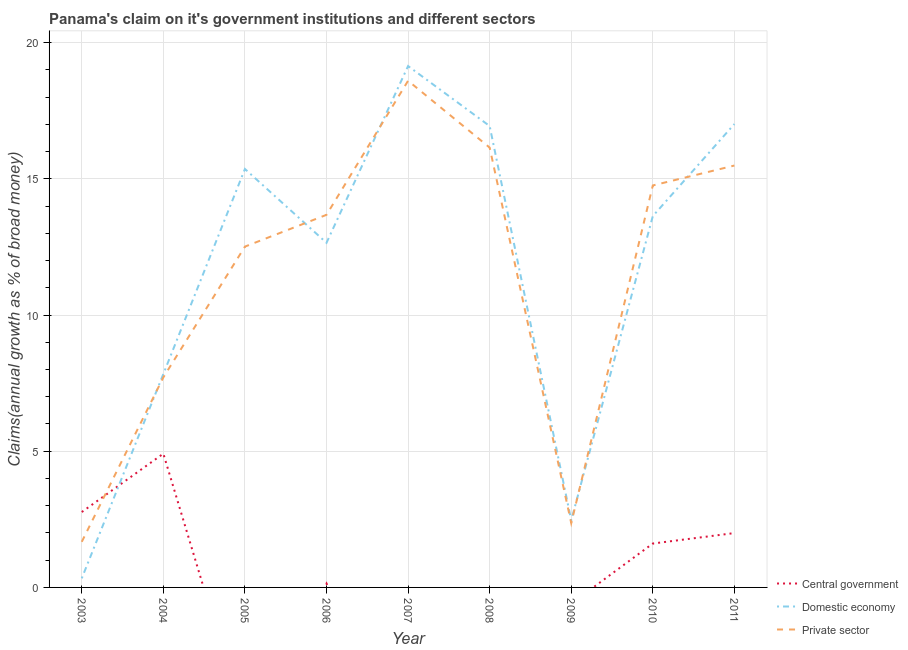Is the number of lines equal to the number of legend labels?
Offer a very short reply. No. What is the percentage of claim on the domestic economy in 2004?
Your response must be concise. 7.83. Across all years, what is the maximum percentage of claim on the domestic economy?
Your answer should be very brief. 19.14. Across all years, what is the minimum percentage of claim on the domestic economy?
Make the answer very short. 0.33. What is the total percentage of claim on the private sector in the graph?
Your answer should be compact. 102.94. What is the difference between the percentage of claim on the central government in 2006 and that in 2011?
Ensure brevity in your answer.  -1.85. What is the difference between the percentage of claim on the central government in 2004 and the percentage of claim on the domestic economy in 2005?
Make the answer very short. -10.45. What is the average percentage of claim on the central government per year?
Ensure brevity in your answer.  1.27. In the year 2009, what is the difference between the percentage of claim on the private sector and percentage of claim on the domestic economy?
Your answer should be very brief. -0.1. In how many years, is the percentage of claim on the private sector greater than 10 %?
Provide a succinct answer. 6. What is the ratio of the percentage of claim on the private sector in 2008 to that in 2010?
Provide a short and direct response. 1.09. Is the percentage of claim on the private sector in 2005 less than that in 2010?
Your response must be concise. Yes. Is the difference between the percentage of claim on the domestic economy in 2007 and 2011 greater than the difference between the percentage of claim on the private sector in 2007 and 2011?
Keep it short and to the point. No. What is the difference between the highest and the second highest percentage of claim on the central government?
Keep it short and to the point. 2.14. What is the difference between the highest and the lowest percentage of claim on the domestic economy?
Give a very brief answer. 18.81. In how many years, is the percentage of claim on the central government greater than the average percentage of claim on the central government taken over all years?
Give a very brief answer. 4. Is the sum of the percentage of claim on the domestic economy in 2005 and 2008 greater than the maximum percentage of claim on the private sector across all years?
Provide a short and direct response. Yes. Is it the case that in every year, the sum of the percentage of claim on the central government and percentage of claim on the domestic economy is greater than the percentage of claim on the private sector?
Provide a short and direct response. No. Does the percentage of claim on the private sector monotonically increase over the years?
Offer a very short reply. No. Is the percentage of claim on the private sector strictly greater than the percentage of claim on the central government over the years?
Your answer should be compact. No. How many lines are there?
Your response must be concise. 3. How many years are there in the graph?
Offer a terse response. 9. What is the difference between two consecutive major ticks on the Y-axis?
Provide a short and direct response. 5. Does the graph contain grids?
Provide a succinct answer. Yes. How many legend labels are there?
Provide a succinct answer. 3. What is the title of the graph?
Give a very brief answer. Panama's claim on it's government institutions and different sectors. What is the label or title of the Y-axis?
Provide a succinct answer. Claims(annual growth as % of broad money). What is the Claims(annual growth as % of broad money) in Central government in 2003?
Make the answer very short. 2.77. What is the Claims(annual growth as % of broad money) of Domestic economy in 2003?
Offer a terse response. 0.33. What is the Claims(annual growth as % of broad money) of Private sector in 2003?
Offer a very short reply. 1.67. What is the Claims(annual growth as % of broad money) in Central government in 2004?
Make the answer very short. 4.91. What is the Claims(annual growth as % of broad money) in Domestic economy in 2004?
Provide a short and direct response. 7.83. What is the Claims(annual growth as % of broad money) of Private sector in 2004?
Your answer should be compact. 7.71. What is the Claims(annual growth as % of broad money) of Domestic economy in 2005?
Give a very brief answer. 15.36. What is the Claims(annual growth as % of broad money) of Private sector in 2005?
Give a very brief answer. 12.51. What is the Claims(annual growth as % of broad money) in Central government in 2006?
Provide a short and direct response. 0.14. What is the Claims(annual growth as % of broad money) in Domestic economy in 2006?
Provide a short and direct response. 12.65. What is the Claims(annual growth as % of broad money) of Private sector in 2006?
Ensure brevity in your answer.  13.68. What is the Claims(annual growth as % of broad money) in Domestic economy in 2007?
Ensure brevity in your answer.  19.14. What is the Claims(annual growth as % of broad money) of Private sector in 2007?
Give a very brief answer. 18.6. What is the Claims(annual growth as % of broad money) of Central government in 2008?
Your answer should be very brief. 0. What is the Claims(annual growth as % of broad money) of Domestic economy in 2008?
Give a very brief answer. 16.94. What is the Claims(annual growth as % of broad money) of Private sector in 2008?
Your answer should be compact. 16.15. What is the Claims(annual growth as % of broad money) in Central government in 2009?
Ensure brevity in your answer.  0. What is the Claims(annual growth as % of broad money) of Domestic economy in 2009?
Provide a short and direct response. 2.46. What is the Claims(annual growth as % of broad money) of Private sector in 2009?
Your response must be concise. 2.36. What is the Claims(annual growth as % of broad money) in Central government in 2010?
Provide a short and direct response. 1.61. What is the Claims(annual growth as % of broad money) of Domestic economy in 2010?
Ensure brevity in your answer.  13.63. What is the Claims(annual growth as % of broad money) in Private sector in 2010?
Provide a succinct answer. 14.76. What is the Claims(annual growth as % of broad money) of Central government in 2011?
Provide a short and direct response. 2. What is the Claims(annual growth as % of broad money) in Domestic economy in 2011?
Make the answer very short. 17.01. What is the Claims(annual growth as % of broad money) in Private sector in 2011?
Your answer should be very brief. 15.49. Across all years, what is the maximum Claims(annual growth as % of broad money) of Central government?
Offer a terse response. 4.91. Across all years, what is the maximum Claims(annual growth as % of broad money) in Domestic economy?
Your response must be concise. 19.14. Across all years, what is the maximum Claims(annual growth as % of broad money) of Private sector?
Your answer should be compact. 18.6. Across all years, what is the minimum Claims(annual growth as % of broad money) in Central government?
Ensure brevity in your answer.  0. Across all years, what is the minimum Claims(annual growth as % of broad money) of Domestic economy?
Offer a terse response. 0.33. Across all years, what is the minimum Claims(annual growth as % of broad money) in Private sector?
Your answer should be compact. 1.67. What is the total Claims(annual growth as % of broad money) in Central government in the graph?
Give a very brief answer. 11.43. What is the total Claims(annual growth as % of broad money) in Domestic economy in the graph?
Ensure brevity in your answer.  105.37. What is the total Claims(annual growth as % of broad money) in Private sector in the graph?
Your answer should be very brief. 102.94. What is the difference between the Claims(annual growth as % of broad money) in Central government in 2003 and that in 2004?
Your answer should be compact. -2.14. What is the difference between the Claims(annual growth as % of broad money) of Domestic economy in 2003 and that in 2004?
Provide a short and direct response. -7.5. What is the difference between the Claims(annual growth as % of broad money) in Private sector in 2003 and that in 2004?
Provide a short and direct response. -6.04. What is the difference between the Claims(annual growth as % of broad money) in Domestic economy in 2003 and that in 2005?
Your answer should be compact. -15.03. What is the difference between the Claims(annual growth as % of broad money) in Private sector in 2003 and that in 2005?
Your response must be concise. -10.84. What is the difference between the Claims(annual growth as % of broad money) of Central government in 2003 and that in 2006?
Your answer should be compact. 2.62. What is the difference between the Claims(annual growth as % of broad money) in Domestic economy in 2003 and that in 2006?
Your answer should be very brief. -12.32. What is the difference between the Claims(annual growth as % of broad money) in Private sector in 2003 and that in 2006?
Keep it short and to the point. -12. What is the difference between the Claims(annual growth as % of broad money) of Domestic economy in 2003 and that in 2007?
Offer a very short reply. -18.81. What is the difference between the Claims(annual growth as % of broad money) in Private sector in 2003 and that in 2007?
Offer a very short reply. -16.93. What is the difference between the Claims(annual growth as % of broad money) of Domestic economy in 2003 and that in 2008?
Make the answer very short. -16.61. What is the difference between the Claims(annual growth as % of broad money) of Private sector in 2003 and that in 2008?
Provide a short and direct response. -14.47. What is the difference between the Claims(annual growth as % of broad money) of Domestic economy in 2003 and that in 2009?
Ensure brevity in your answer.  -2.13. What is the difference between the Claims(annual growth as % of broad money) of Private sector in 2003 and that in 2009?
Offer a terse response. -0.69. What is the difference between the Claims(annual growth as % of broad money) of Central government in 2003 and that in 2010?
Offer a terse response. 1.16. What is the difference between the Claims(annual growth as % of broad money) in Domestic economy in 2003 and that in 2010?
Give a very brief answer. -13.3. What is the difference between the Claims(annual growth as % of broad money) of Private sector in 2003 and that in 2010?
Provide a succinct answer. -13.08. What is the difference between the Claims(annual growth as % of broad money) of Central government in 2003 and that in 2011?
Make the answer very short. 0.77. What is the difference between the Claims(annual growth as % of broad money) of Domestic economy in 2003 and that in 2011?
Provide a short and direct response. -16.68. What is the difference between the Claims(annual growth as % of broad money) of Private sector in 2003 and that in 2011?
Your answer should be compact. -13.81. What is the difference between the Claims(annual growth as % of broad money) of Domestic economy in 2004 and that in 2005?
Your answer should be compact. -7.53. What is the difference between the Claims(annual growth as % of broad money) of Private sector in 2004 and that in 2005?
Provide a succinct answer. -4.8. What is the difference between the Claims(annual growth as % of broad money) in Central government in 2004 and that in 2006?
Your answer should be compact. 4.77. What is the difference between the Claims(annual growth as % of broad money) of Domestic economy in 2004 and that in 2006?
Make the answer very short. -4.82. What is the difference between the Claims(annual growth as % of broad money) in Private sector in 2004 and that in 2006?
Offer a very short reply. -5.97. What is the difference between the Claims(annual growth as % of broad money) of Domestic economy in 2004 and that in 2007?
Give a very brief answer. -11.31. What is the difference between the Claims(annual growth as % of broad money) of Private sector in 2004 and that in 2007?
Provide a succinct answer. -10.89. What is the difference between the Claims(annual growth as % of broad money) of Domestic economy in 2004 and that in 2008?
Keep it short and to the point. -9.1. What is the difference between the Claims(annual growth as % of broad money) of Private sector in 2004 and that in 2008?
Keep it short and to the point. -8.44. What is the difference between the Claims(annual growth as % of broad money) in Domestic economy in 2004 and that in 2009?
Give a very brief answer. 5.37. What is the difference between the Claims(annual growth as % of broad money) in Private sector in 2004 and that in 2009?
Provide a succinct answer. 5.35. What is the difference between the Claims(annual growth as % of broad money) of Central government in 2004 and that in 2010?
Your answer should be compact. 3.3. What is the difference between the Claims(annual growth as % of broad money) in Domestic economy in 2004 and that in 2010?
Provide a succinct answer. -5.8. What is the difference between the Claims(annual growth as % of broad money) in Private sector in 2004 and that in 2010?
Keep it short and to the point. -7.05. What is the difference between the Claims(annual growth as % of broad money) in Central government in 2004 and that in 2011?
Your answer should be compact. 2.92. What is the difference between the Claims(annual growth as % of broad money) in Domestic economy in 2004 and that in 2011?
Provide a short and direct response. -9.18. What is the difference between the Claims(annual growth as % of broad money) of Private sector in 2004 and that in 2011?
Offer a terse response. -7.78. What is the difference between the Claims(annual growth as % of broad money) of Domestic economy in 2005 and that in 2006?
Offer a very short reply. 2.71. What is the difference between the Claims(annual growth as % of broad money) in Private sector in 2005 and that in 2006?
Ensure brevity in your answer.  -1.17. What is the difference between the Claims(annual growth as % of broad money) in Domestic economy in 2005 and that in 2007?
Your answer should be compact. -3.78. What is the difference between the Claims(annual growth as % of broad money) of Private sector in 2005 and that in 2007?
Make the answer very short. -6.09. What is the difference between the Claims(annual growth as % of broad money) in Domestic economy in 2005 and that in 2008?
Your response must be concise. -1.58. What is the difference between the Claims(annual growth as % of broad money) of Private sector in 2005 and that in 2008?
Ensure brevity in your answer.  -3.64. What is the difference between the Claims(annual growth as % of broad money) of Domestic economy in 2005 and that in 2009?
Your answer should be compact. 12.9. What is the difference between the Claims(annual growth as % of broad money) of Private sector in 2005 and that in 2009?
Your answer should be very brief. 10.15. What is the difference between the Claims(annual growth as % of broad money) of Domestic economy in 2005 and that in 2010?
Ensure brevity in your answer.  1.73. What is the difference between the Claims(annual growth as % of broad money) of Private sector in 2005 and that in 2010?
Offer a terse response. -2.25. What is the difference between the Claims(annual growth as % of broad money) of Domestic economy in 2005 and that in 2011?
Provide a succinct answer. -1.65. What is the difference between the Claims(annual growth as % of broad money) of Private sector in 2005 and that in 2011?
Keep it short and to the point. -2.98. What is the difference between the Claims(annual growth as % of broad money) in Domestic economy in 2006 and that in 2007?
Ensure brevity in your answer.  -6.49. What is the difference between the Claims(annual growth as % of broad money) in Private sector in 2006 and that in 2007?
Keep it short and to the point. -4.92. What is the difference between the Claims(annual growth as % of broad money) of Domestic economy in 2006 and that in 2008?
Your answer should be very brief. -4.29. What is the difference between the Claims(annual growth as % of broad money) of Private sector in 2006 and that in 2008?
Ensure brevity in your answer.  -2.47. What is the difference between the Claims(annual growth as % of broad money) in Domestic economy in 2006 and that in 2009?
Keep it short and to the point. 10.19. What is the difference between the Claims(annual growth as % of broad money) of Private sector in 2006 and that in 2009?
Offer a very short reply. 11.32. What is the difference between the Claims(annual growth as % of broad money) of Central government in 2006 and that in 2010?
Keep it short and to the point. -1.47. What is the difference between the Claims(annual growth as % of broad money) in Domestic economy in 2006 and that in 2010?
Provide a short and direct response. -0.98. What is the difference between the Claims(annual growth as % of broad money) of Private sector in 2006 and that in 2010?
Provide a short and direct response. -1.08. What is the difference between the Claims(annual growth as % of broad money) in Central government in 2006 and that in 2011?
Provide a succinct answer. -1.85. What is the difference between the Claims(annual growth as % of broad money) of Domestic economy in 2006 and that in 2011?
Offer a terse response. -4.36. What is the difference between the Claims(annual growth as % of broad money) in Private sector in 2006 and that in 2011?
Your response must be concise. -1.81. What is the difference between the Claims(annual growth as % of broad money) of Domestic economy in 2007 and that in 2008?
Your answer should be compact. 2.2. What is the difference between the Claims(annual growth as % of broad money) of Private sector in 2007 and that in 2008?
Keep it short and to the point. 2.45. What is the difference between the Claims(annual growth as % of broad money) of Domestic economy in 2007 and that in 2009?
Offer a very short reply. 16.68. What is the difference between the Claims(annual growth as % of broad money) in Private sector in 2007 and that in 2009?
Give a very brief answer. 16.24. What is the difference between the Claims(annual growth as % of broad money) in Domestic economy in 2007 and that in 2010?
Offer a terse response. 5.51. What is the difference between the Claims(annual growth as % of broad money) of Private sector in 2007 and that in 2010?
Your answer should be very brief. 3.84. What is the difference between the Claims(annual growth as % of broad money) in Domestic economy in 2007 and that in 2011?
Your response must be concise. 2.13. What is the difference between the Claims(annual growth as % of broad money) of Private sector in 2007 and that in 2011?
Your answer should be compact. 3.11. What is the difference between the Claims(annual growth as % of broad money) in Domestic economy in 2008 and that in 2009?
Provide a short and direct response. 14.48. What is the difference between the Claims(annual growth as % of broad money) in Private sector in 2008 and that in 2009?
Your response must be concise. 13.78. What is the difference between the Claims(annual growth as % of broad money) in Domestic economy in 2008 and that in 2010?
Give a very brief answer. 3.31. What is the difference between the Claims(annual growth as % of broad money) in Private sector in 2008 and that in 2010?
Your response must be concise. 1.39. What is the difference between the Claims(annual growth as % of broad money) of Domestic economy in 2008 and that in 2011?
Provide a succinct answer. -0.07. What is the difference between the Claims(annual growth as % of broad money) in Private sector in 2008 and that in 2011?
Offer a terse response. 0.66. What is the difference between the Claims(annual growth as % of broad money) of Domestic economy in 2009 and that in 2010?
Provide a succinct answer. -11.17. What is the difference between the Claims(annual growth as % of broad money) in Private sector in 2009 and that in 2010?
Ensure brevity in your answer.  -12.39. What is the difference between the Claims(annual growth as % of broad money) of Domestic economy in 2009 and that in 2011?
Your answer should be compact. -14.55. What is the difference between the Claims(annual growth as % of broad money) in Private sector in 2009 and that in 2011?
Offer a terse response. -13.13. What is the difference between the Claims(annual growth as % of broad money) in Central government in 2010 and that in 2011?
Give a very brief answer. -0.38. What is the difference between the Claims(annual growth as % of broad money) in Domestic economy in 2010 and that in 2011?
Give a very brief answer. -3.38. What is the difference between the Claims(annual growth as % of broad money) of Private sector in 2010 and that in 2011?
Your response must be concise. -0.73. What is the difference between the Claims(annual growth as % of broad money) of Central government in 2003 and the Claims(annual growth as % of broad money) of Domestic economy in 2004?
Your response must be concise. -5.07. What is the difference between the Claims(annual growth as % of broad money) in Central government in 2003 and the Claims(annual growth as % of broad money) in Private sector in 2004?
Your answer should be compact. -4.94. What is the difference between the Claims(annual growth as % of broad money) in Domestic economy in 2003 and the Claims(annual growth as % of broad money) in Private sector in 2004?
Provide a short and direct response. -7.38. What is the difference between the Claims(annual growth as % of broad money) of Central government in 2003 and the Claims(annual growth as % of broad money) of Domestic economy in 2005?
Offer a very short reply. -12.59. What is the difference between the Claims(annual growth as % of broad money) in Central government in 2003 and the Claims(annual growth as % of broad money) in Private sector in 2005?
Your answer should be very brief. -9.74. What is the difference between the Claims(annual growth as % of broad money) of Domestic economy in 2003 and the Claims(annual growth as % of broad money) of Private sector in 2005?
Your answer should be very brief. -12.18. What is the difference between the Claims(annual growth as % of broad money) in Central government in 2003 and the Claims(annual growth as % of broad money) in Domestic economy in 2006?
Make the answer very short. -9.88. What is the difference between the Claims(annual growth as % of broad money) of Central government in 2003 and the Claims(annual growth as % of broad money) of Private sector in 2006?
Ensure brevity in your answer.  -10.91. What is the difference between the Claims(annual growth as % of broad money) in Domestic economy in 2003 and the Claims(annual growth as % of broad money) in Private sector in 2006?
Offer a very short reply. -13.35. What is the difference between the Claims(annual growth as % of broad money) in Central government in 2003 and the Claims(annual growth as % of broad money) in Domestic economy in 2007?
Your answer should be very brief. -16.37. What is the difference between the Claims(annual growth as % of broad money) in Central government in 2003 and the Claims(annual growth as % of broad money) in Private sector in 2007?
Your answer should be very brief. -15.83. What is the difference between the Claims(annual growth as % of broad money) in Domestic economy in 2003 and the Claims(annual growth as % of broad money) in Private sector in 2007?
Make the answer very short. -18.27. What is the difference between the Claims(annual growth as % of broad money) in Central government in 2003 and the Claims(annual growth as % of broad money) in Domestic economy in 2008?
Keep it short and to the point. -14.17. What is the difference between the Claims(annual growth as % of broad money) in Central government in 2003 and the Claims(annual growth as % of broad money) in Private sector in 2008?
Provide a succinct answer. -13.38. What is the difference between the Claims(annual growth as % of broad money) in Domestic economy in 2003 and the Claims(annual growth as % of broad money) in Private sector in 2008?
Give a very brief answer. -15.81. What is the difference between the Claims(annual growth as % of broad money) in Central government in 2003 and the Claims(annual growth as % of broad money) in Domestic economy in 2009?
Give a very brief answer. 0.31. What is the difference between the Claims(annual growth as % of broad money) in Central government in 2003 and the Claims(annual growth as % of broad money) in Private sector in 2009?
Offer a very short reply. 0.4. What is the difference between the Claims(annual growth as % of broad money) of Domestic economy in 2003 and the Claims(annual growth as % of broad money) of Private sector in 2009?
Provide a succinct answer. -2.03. What is the difference between the Claims(annual growth as % of broad money) of Central government in 2003 and the Claims(annual growth as % of broad money) of Domestic economy in 2010?
Provide a short and direct response. -10.86. What is the difference between the Claims(annual growth as % of broad money) of Central government in 2003 and the Claims(annual growth as % of broad money) of Private sector in 2010?
Ensure brevity in your answer.  -11.99. What is the difference between the Claims(annual growth as % of broad money) in Domestic economy in 2003 and the Claims(annual growth as % of broad money) in Private sector in 2010?
Your answer should be very brief. -14.42. What is the difference between the Claims(annual growth as % of broad money) of Central government in 2003 and the Claims(annual growth as % of broad money) of Domestic economy in 2011?
Provide a short and direct response. -14.24. What is the difference between the Claims(annual growth as % of broad money) of Central government in 2003 and the Claims(annual growth as % of broad money) of Private sector in 2011?
Give a very brief answer. -12.72. What is the difference between the Claims(annual growth as % of broad money) in Domestic economy in 2003 and the Claims(annual growth as % of broad money) in Private sector in 2011?
Your answer should be very brief. -15.15. What is the difference between the Claims(annual growth as % of broad money) of Central government in 2004 and the Claims(annual growth as % of broad money) of Domestic economy in 2005?
Give a very brief answer. -10.45. What is the difference between the Claims(annual growth as % of broad money) of Central government in 2004 and the Claims(annual growth as % of broad money) of Private sector in 2005?
Your answer should be compact. -7.6. What is the difference between the Claims(annual growth as % of broad money) in Domestic economy in 2004 and the Claims(annual growth as % of broad money) in Private sector in 2005?
Offer a very short reply. -4.68. What is the difference between the Claims(annual growth as % of broad money) of Central government in 2004 and the Claims(annual growth as % of broad money) of Domestic economy in 2006?
Provide a succinct answer. -7.74. What is the difference between the Claims(annual growth as % of broad money) in Central government in 2004 and the Claims(annual growth as % of broad money) in Private sector in 2006?
Offer a terse response. -8.77. What is the difference between the Claims(annual growth as % of broad money) of Domestic economy in 2004 and the Claims(annual growth as % of broad money) of Private sector in 2006?
Provide a short and direct response. -5.84. What is the difference between the Claims(annual growth as % of broad money) in Central government in 2004 and the Claims(annual growth as % of broad money) in Domestic economy in 2007?
Offer a terse response. -14.23. What is the difference between the Claims(annual growth as % of broad money) of Central government in 2004 and the Claims(annual growth as % of broad money) of Private sector in 2007?
Your response must be concise. -13.69. What is the difference between the Claims(annual growth as % of broad money) in Domestic economy in 2004 and the Claims(annual growth as % of broad money) in Private sector in 2007?
Make the answer very short. -10.77. What is the difference between the Claims(annual growth as % of broad money) of Central government in 2004 and the Claims(annual growth as % of broad money) of Domestic economy in 2008?
Ensure brevity in your answer.  -12.03. What is the difference between the Claims(annual growth as % of broad money) of Central government in 2004 and the Claims(annual growth as % of broad money) of Private sector in 2008?
Offer a terse response. -11.24. What is the difference between the Claims(annual growth as % of broad money) in Domestic economy in 2004 and the Claims(annual growth as % of broad money) in Private sector in 2008?
Ensure brevity in your answer.  -8.31. What is the difference between the Claims(annual growth as % of broad money) in Central government in 2004 and the Claims(annual growth as % of broad money) in Domestic economy in 2009?
Your response must be concise. 2.45. What is the difference between the Claims(annual growth as % of broad money) in Central government in 2004 and the Claims(annual growth as % of broad money) in Private sector in 2009?
Offer a terse response. 2.55. What is the difference between the Claims(annual growth as % of broad money) of Domestic economy in 2004 and the Claims(annual growth as % of broad money) of Private sector in 2009?
Offer a very short reply. 5.47. What is the difference between the Claims(annual growth as % of broad money) of Central government in 2004 and the Claims(annual growth as % of broad money) of Domestic economy in 2010?
Your answer should be very brief. -8.72. What is the difference between the Claims(annual growth as % of broad money) in Central government in 2004 and the Claims(annual growth as % of broad money) in Private sector in 2010?
Your answer should be compact. -9.85. What is the difference between the Claims(annual growth as % of broad money) in Domestic economy in 2004 and the Claims(annual growth as % of broad money) in Private sector in 2010?
Offer a terse response. -6.92. What is the difference between the Claims(annual growth as % of broad money) in Central government in 2004 and the Claims(annual growth as % of broad money) in Domestic economy in 2011?
Offer a terse response. -12.1. What is the difference between the Claims(annual growth as % of broad money) in Central government in 2004 and the Claims(annual growth as % of broad money) in Private sector in 2011?
Your answer should be compact. -10.58. What is the difference between the Claims(annual growth as % of broad money) of Domestic economy in 2004 and the Claims(annual growth as % of broad money) of Private sector in 2011?
Give a very brief answer. -7.65. What is the difference between the Claims(annual growth as % of broad money) of Domestic economy in 2005 and the Claims(annual growth as % of broad money) of Private sector in 2006?
Give a very brief answer. 1.68. What is the difference between the Claims(annual growth as % of broad money) in Domestic economy in 2005 and the Claims(annual growth as % of broad money) in Private sector in 2007?
Your answer should be very brief. -3.24. What is the difference between the Claims(annual growth as % of broad money) of Domestic economy in 2005 and the Claims(annual growth as % of broad money) of Private sector in 2008?
Provide a succinct answer. -0.78. What is the difference between the Claims(annual growth as % of broad money) of Domestic economy in 2005 and the Claims(annual growth as % of broad money) of Private sector in 2009?
Give a very brief answer. 13. What is the difference between the Claims(annual growth as % of broad money) of Domestic economy in 2005 and the Claims(annual growth as % of broad money) of Private sector in 2010?
Your response must be concise. 0.6. What is the difference between the Claims(annual growth as % of broad money) in Domestic economy in 2005 and the Claims(annual growth as % of broad money) in Private sector in 2011?
Make the answer very short. -0.13. What is the difference between the Claims(annual growth as % of broad money) in Central government in 2006 and the Claims(annual growth as % of broad money) in Domestic economy in 2007?
Offer a terse response. -19. What is the difference between the Claims(annual growth as % of broad money) of Central government in 2006 and the Claims(annual growth as % of broad money) of Private sector in 2007?
Ensure brevity in your answer.  -18.46. What is the difference between the Claims(annual growth as % of broad money) of Domestic economy in 2006 and the Claims(annual growth as % of broad money) of Private sector in 2007?
Provide a short and direct response. -5.95. What is the difference between the Claims(annual growth as % of broad money) of Central government in 2006 and the Claims(annual growth as % of broad money) of Domestic economy in 2008?
Your answer should be very brief. -16.79. What is the difference between the Claims(annual growth as % of broad money) in Central government in 2006 and the Claims(annual growth as % of broad money) in Private sector in 2008?
Your answer should be very brief. -16. What is the difference between the Claims(annual growth as % of broad money) in Domestic economy in 2006 and the Claims(annual growth as % of broad money) in Private sector in 2008?
Make the answer very short. -3.5. What is the difference between the Claims(annual growth as % of broad money) of Central government in 2006 and the Claims(annual growth as % of broad money) of Domestic economy in 2009?
Offer a very short reply. -2.32. What is the difference between the Claims(annual growth as % of broad money) of Central government in 2006 and the Claims(annual growth as % of broad money) of Private sector in 2009?
Ensure brevity in your answer.  -2.22. What is the difference between the Claims(annual growth as % of broad money) in Domestic economy in 2006 and the Claims(annual growth as % of broad money) in Private sector in 2009?
Your answer should be compact. 10.29. What is the difference between the Claims(annual growth as % of broad money) of Central government in 2006 and the Claims(annual growth as % of broad money) of Domestic economy in 2010?
Give a very brief answer. -13.49. What is the difference between the Claims(annual growth as % of broad money) of Central government in 2006 and the Claims(annual growth as % of broad money) of Private sector in 2010?
Make the answer very short. -14.61. What is the difference between the Claims(annual growth as % of broad money) of Domestic economy in 2006 and the Claims(annual growth as % of broad money) of Private sector in 2010?
Provide a short and direct response. -2.11. What is the difference between the Claims(annual growth as % of broad money) of Central government in 2006 and the Claims(annual growth as % of broad money) of Domestic economy in 2011?
Ensure brevity in your answer.  -16.87. What is the difference between the Claims(annual growth as % of broad money) in Central government in 2006 and the Claims(annual growth as % of broad money) in Private sector in 2011?
Your answer should be very brief. -15.34. What is the difference between the Claims(annual growth as % of broad money) in Domestic economy in 2006 and the Claims(annual growth as % of broad money) in Private sector in 2011?
Ensure brevity in your answer.  -2.84. What is the difference between the Claims(annual growth as % of broad money) of Domestic economy in 2007 and the Claims(annual growth as % of broad money) of Private sector in 2008?
Keep it short and to the point. 2.99. What is the difference between the Claims(annual growth as % of broad money) in Domestic economy in 2007 and the Claims(annual growth as % of broad money) in Private sector in 2009?
Keep it short and to the point. 16.78. What is the difference between the Claims(annual growth as % of broad money) in Domestic economy in 2007 and the Claims(annual growth as % of broad money) in Private sector in 2010?
Your answer should be very brief. 4.38. What is the difference between the Claims(annual growth as % of broad money) in Domestic economy in 2007 and the Claims(annual growth as % of broad money) in Private sector in 2011?
Offer a terse response. 3.65. What is the difference between the Claims(annual growth as % of broad money) of Domestic economy in 2008 and the Claims(annual growth as % of broad money) of Private sector in 2009?
Your response must be concise. 14.58. What is the difference between the Claims(annual growth as % of broad money) in Domestic economy in 2008 and the Claims(annual growth as % of broad money) in Private sector in 2010?
Your answer should be very brief. 2.18. What is the difference between the Claims(annual growth as % of broad money) in Domestic economy in 2008 and the Claims(annual growth as % of broad money) in Private sector in 2011?
Provide a short and direct response. 1.45. What is the difference between the Claims(annual growth as % of broad money) in Domestic economy in 2009 and the Claims(annual growth as % of broad money) in Private sector in 2010?
Offer a terse response. -12.3. What is the difference between the Claims(annual growth as % of broad money) of Domestic economy in 2009 and the Claims(annual growth as % of broad money) of Private sector in 2011?
Make the answer very short. -13.03. What is the difference between the Claims(annual growth as % of broad money) of Central government in 2010 and the Claims(annual growth as % of broad money) of Domestic economy in 2011?
Your answer should be very brief. -15.4. What is the difference between the Claims(annual growth as % of broad money) of Central government in 2010 and the Claims(annual growth as % of broad money) of Private sector in 2011?
Ensure brevity in your answer.  -13.88. What is the difference between the Claims(annual growth as % of broad money) of Domestic economy in 2010 and the Claims(annual growth as % of broad money) of Private sector in 2011?
Offer a very short reply. -1.86. What is the average Claims(annual growth as % of broad money) of Central government per year?
Offer a terse response. 1.27. What is the average Claims(annual growth as % of broad money) of Domestic economy per year?
Your answer should be very brief. 11.71. What is the average Claims(annual growth as % of broad money) of Private sector per year?
Ensure brevity in your answer.  11.44. In the year 2003, what is the difference between the Claims(annual growth as % of broad money) of Central government and Claims(annual growth as % of broad money) of Domestic economy?
Your response must be concise. 2.43. In the year 2003, what is the difference between the Claims(annual growth as % of broad money) of Central government and Claims(annual growth as % of broad money) of Private sector?
Provide a short and direct response. 1.09. In the year 2003, what is the difference between the Claims(annual growth as % of broad money) of Domestic economy and Claims(annual growth as % of broad money) of Private sector?
Your response must be concise. -1.34. In the year 2004, what is the difference between the Claims(annual growth as % of broad money) of Central government and Claims(annual growth as % of broad money) of Domestic economy?
Your answer should be compact. -2.92. In the year 2004, what is the difference between the Claims(annual growth as % of broad money) in Central government and Claims(annual growth as % of broad money) in Private sector?
Make the answer very short. -2.8. In the year 2004, what is the difference between the Claims(annual growth as % of broad money) of Domestic economy and Claims(annual growth as % of broad money) of Private sector?
Your answer should be compact. 0.12. In the year 2005, what is the difference between the Claims(annual growth as % of broad money) of Domestic economy and Claims(annual growth as % of broad money) of Private sector?
Your response must be concise. 2.85. In the year 2006, what is the difference between the Claims(annual growth as % of broad money) of Central government and Claims(annual growth as % of broad money) of Domestic economy?
Your response must be concise. -12.51. In the year 2006, what is the difference between the Claims(annual growth as % of broad money) in Central government and Claims(annual growth as % of broad money) in Private sector?
Keep it short and to the point. -13.53. In the year 2006, what is the difference between the Claims(annual growth as % of broad money) in Domestic economy and Claims(annual growth as % of broad money) in Private sector?
Ensure brevity in your answer.  -1.03. In the year 2007, what is the difference between the Claims(annual growth as % of broad money) in Domestic economy and Claims(annual growth as % of broad money) in Private sector?
Make the answer very short. 0.54. In the year 2008, what is the difference between the Claims(annual growth as % of broad money) of Domestic economy and Claims(annual growth as % of broad money) of Private sector?
Your answer should be compact. 0.79. In the year 2009, what is the difference between the Claims(annual growth as % of broad money) in Domestic economy and Claims(annual growth as % of broad money) in Private sector?
Offer a very short reply. 0.1. In the year 2010, what is the difference between the Claims(annual growth as % of broad money) in Central government and Claims(annual growth as % of broad money) in Domestic economy?
Ensure brevity in your answer.  -12.02. In the year 2010, what is the difference between the Claims(annual growth as % of broad money) of Central government and Claims(annual growth as % of broad money) of Private sector?
Provide a short and direct response. -13.15. In the year 2010, what is the difference between the Claims(annual growth as % of broad money) of Domestic economy and Claims(annual growth as % of broad money) of Private sector?
Your response must be concise. -1.13. In the year 2011, what is the difference between the Claims(annual growth as % of broad money) in Central government and Claims(annual growth as % of broad money) in Domestic economy?
Give a very brief answer. -15.02. In the year 2011, what is the difference between the Claims(annual growth as % of broad money) of Central government and Claims(annual growth as % of broad money) of Private sector?
Provide a succinct answer. -13.49. In the year 2011, what is the difference between the Claims(annual growth as % of broad money) in Domestic economy and Claims(annual growth as % of broad money) in Private sector?
Provide a short and direct response. 1.52. What is the ratio of the Claims(annual growth as % of broad money) of Central government in 2003 to that in 2004?
Offer a very short reply. 0.56. What is the ratio of the Claims(annual growth as % of broad money) of Domestic economy in 2003 to that in 2004?
Ensure brevity in your answer.  0.04. What is the ratio of the Claims(annual growth as % of broad money) of Private sector in 2003 to that in 2004?
Provide a short and direct response. 0.22. What is the ratio of the Claims(annual growth as % of broad money) in Domestic economy in 2003 to that in 2005?
Your answer should be very brief. 0.02. What is the ratio of the Claims(annual growth as % of broad money) in Private sector in 2003 to that in 2005?
Ensure brevity in your answer.  0.13. What is the ratio of the Claims(annual growth as % of broad money) of Central government in 2003 to that in 2006?
Your answer should be very brief. 19.18. What is the ratio of the Claims(annual growth as % of broad money) in Domestic economy in 2003 to that in 2006?
Your answer should be very brief. 0.03. What is the ratio of the Claims(annual growth as % of broad money) in Private sector in 2003 to that in 2006?
Provide a short and direct response. 0.12. What is the ratio of the Claims(annual growth as % of broad money) of Domestic economy in 2003 to that in 2007?
Give a very brief answer. 0.02. What is the ratio of the Claims(annual growth as % of broad money) of Private sector in 2003 to that in 2007?
Your response must be concise. 0.09. What is the ratio of the Claims(annual growth as % of broad money) of Domestic economy in 2003 to that in 2008?
Your answer should be compact. 0.02. What is the ratio of the Claims(annual growth as % of broad money) in Private sector in 2003 to that in 2008?
Ensure brevity in your answer.  0.1. What is the ratio of the Claims(annual growth as % of broad money) in Domestic economy in 2003 to that in 2009?
Ensure brevity in your answer.  0.14. What is the ratio of the Claims(annual growth as % of broad money) in Private sector in 2003 to that in 2009?
Keep it short and to the point. 0.71. What is the ratio of the Claims(annual growth as % of broad money) in Central government in 2003 to that in 2010?
Offer a very short reply. 1.72. What is the ratio of the Claims(annual growth as % of broad money) in Domestic economy in 2003 to that in 2010?
Offer a terse response. 0.02. What is the ratio of the Claims(annual growth as % of broad money) in Private sector in 2003 to that in 2010?
Ensure brevity in your answer.  0.11. What is the ratio of the Claims(annual growth as % of broad money) in Central government in 2003 to that in 2011?
Your response must be concise. 1.39. What is the ratio of the Claims(annual growth as % of broad money) in Domestic economy in 2003 to that in 2011?
Provide a succinct answer. 0.02. What is the ratio of the Claims(annual growth as % of broad money) of Private sector in 2003 to that in 2011?
Give a very brief answer. 0.11. What is the ratio of the Claims(annual growth as % of broad money) of Domestic economy in 2004 to that in 2005?
Your answer should be very brief. 0.51. What is the ratio of the Claims(annual growth as % of broad money) in Private sector in 2004 to that in 2005?
Keep it short and to the point. 0.62. What is the ratio of the Claims(annual growth as % of broad money) of Central government in 2004 to that in 2006?
Offer a terse response. 34.04. What is the ratio of the Claims(annual growth as % of broad money) in Domestic economy in 2004 to that in 2006?
Offer a terse response. 0.62. What is the ratio of the Claims(annual growth as % of broad money) of Private sector in 2004 to that in 2006?
Provide a short and direct response. 0.56. What is the ratio of the Claims(annual growth as % of broad money) in Domestic economy in 2004 to that in 2007?
Provide a short and direct response. 0.41. What is the ratio of the Claims(annual growth as % of broad money) in Private sector in 2004 to that in 2007?
Ensure brevity in your answer.  0.41. What is the ratio of the Claims(annual growth as % of broad money) of Domestic economy in 2004 to that in 2008?
Give a very brief answer. 0.46. What is the ratio of the Claims(annual growth as % of broad money) of Private sector in 2004 to that in 2008?
Give a very brief answer. 0.48. What is the ratio of the Claims(annual growth as % of broad money) in Domestic economy in 2004 to that in 2009?
Make the answer very short. 3.18. What is the ratio of the Claims(annual growth as % of broad money) of Private sector in 2004 to that in 2009?
Your response must be concise. 3.26. What is the ratio of the Claims(annual growth as % of broad money) of Central government in 2004 to that in 2010?
Offer a terse response. 3.05. What is the ratio of the Claims(annual growth as % of broad money) in Domestic economy in 2004 to that in 2010?
Give a very brief answer. 0.57. What is the ratio of the Claims(annual growth as % of broad money) of Private sector in 2004 to that in 2010?
Offer a very short reply. 0.52. What is the ratio of the Claims(annual growth as % of broad money) of Central government in 2004 to that in 2011?
Make the answer very short. 2.46. What is the ratio of the Claims(annual growth as % of broad money) in Domestic economy in 2004 to that in 2011?
Keep it short and to the point. 0.46. What is the ratio of the Claims(annual growth as % of broad money) of Private sector in 2004 to that in 2011?
Offer a very short reply. 0.5. What is the ratio of the Claims(annual growth as % of broad money) in Domestic economy in 2005 to that in 2006?
Provide a short and direct response. 1.21. What is the ratio of the Claims(annual growth as % of broad money) of Private sector in 2005 to that in 2006?
Give a very brief answer. 0.91. What is the ratio of the Claims(annual growth as % of broad money) of Domestic economy in 2005 to that in 2007?
Provide a succinct answer. 0.8. What is the ratio of the Claims(annual growth as % of broad money) of Private sector in 2005 to that in 2007?
Provide a short and direct response. 0.67. What is the ratio of the Claims(annual growth as % of broad money) in Domestic economy in 2005 to that in 2008?
Offer a terse response. 0.91. What is the ratio of the Claims(annual growth as % of broad money) in Private sector in 2005 to that in 2008?
Give a very brief answer. 0.77. What is the ratio of the Claims(annual growth as % of broad money) in Domestic economy in 2005 to that in 2009?
Your answer should be very brief. 6.24. What is the ratio of the Claims(annual growth as % of broad money) of Private sector in 2005 to that in 2009?
Offer a very short reply. 5.29. What is the ratio of the Claims(annual growth as % of broad money) in Domestic economy in 2005 to that in 2010?
Offer a terse response. 1.13. What is the ratio of the Claims(annual growth as % of broad money) in Private sector in 2005 to that in 2010?
Provide a short and direct response. 0.85. What is the ratio of the Claims(annual growth as % of broad money) of Domestic economy in 2005 to that in 2011?
Keep it short and to the point. 0.9. What is the ratio of the Claims(annual growth as % of broad money) in Private sector in 2005 to that in 2011?
Give a very brief answer. 0.81. What is the ratio of the Claims(annual growth as % of broad money) of Domestic economy in 2006 to that in 2007?
Your answer should be compact. 0.66. What is the ratio of the Claims(annual growth as % of broad money) in Private sector in 2006 to that in 2007?
Provide a succinct answer. 0.74. What is the ratio of the Claims(annual growth as % of broad money) of Domestic economy in 2006 to that in 2008?
Offer a terse response. 0.75. What is the ratio of the Claims(annual growth as % of broad money) in Private sector in 2006 to that in 2008?
Give a very brief answer. 0.85. What is the ratio of the Claims(annual growth as % of broad money) of Domestic economy in 2006 to that in 2009?
Your answer should be very brief. 5.14. What is the ratio of the Claims(annual growth as % of broad money) in Private sector in 2006 to that in 2009?
Provide a short and direct response. 5.79. What is the ratio of the Claims(annual growth as % of broad money) in Central government in 2006 to that in 2010?
Make the answer very short. 0.09. What is the ratio of the Claims(annual growth as % of broad money) in Domestic economy in 2006 to that in 2010?
Your answer should be very brief. 0.93. What is the ratio of the Claims(annual growth as % of broad money) of Private sector in 2006 to that in 2010?
Provide a succinct answer. 0.93. What is the ratio of the Claims(annual growth as % of broad money) in Central government in 2006 to that in 2011?
Keep it short and to the point. 0.07. What is the ratio of the Claims(annual growth as % of broad money) in Domestic economy in 2006 to that in 2011?
Make the answer very short. 0.74. What is the ratio of the Claims(annual growth as % of broad money) in Private sector in 2006 to that in 2011?
Your answer should be compact. 0.88. What is the ratio of the Claims(annual growth as % of broad money) of Domestic economy in 2007 to that in 2008?
Your answer should be very brief. 1.13. What is the ratio of the Claims(annual growth as % of broad money) of Private sector in 2007 to that in 2008?
Your response must be concise. 1.15. What is the ratio of the Claims(annual growth as % of broad money) of Domestic economy in 2007 to that in 2009?
Provide a succinct answer. 7.77. What is the ratio of the Claims(annual growth as % of broad money) of Private sector in 2007 to that in 2009?
Ensure brevity in your answer.  7.87. What is the ratio of the Claims(annual growth as % of broad money) in Domestic economy in 2007 to that in 2010?
Provide a succinct answer. 1.4. What is the ratio of the Claims(annual growth as % of broad money) in Private sector in 2007 to that in 2010?
Give a very brief answer. 1.26. What is the ratio of the Claims(annual growth as % of broad money) in Domestic economy in 2007 to that in 2011?
Your response must be concise. 1.13. What is the ratio of the Claims(annual growth as % of broad money) of Private sector in 2007 to that in 2011?
Offer a terse response. 1.2. What is the ratio of the Claims(annual growth as % of broad money) of Domestic economy in 2008 to that in 2009?
Provide a short and direct response. 6.88. What is the ratio of the Claims(annual growth as % of broad money) of Private sector in 2008 to that in 2009?
Ensure brevity in your answer.  6.83. What is the ratio of the Claims(annual growth as % of broad money) of Domestic economy in 2008 to that in 2010?
Your response must be concise. 1.24. What is the ratio of the Claims(annual growth as % of broad money) of Private sector in 2008 to that in 2010?
Provide a short and direct response. 1.09. What is the ratio of the Claims(annual growth as % of broad money) of Private sector in 2008 to that in 2011?
Your answer should be very brief. 1.04. What is the ratio of the Claims(annual growth as % of broad money) in Domestic economy in 2009 to that in 2010?
Make the answer very short. 0.18. What is the ratio of the Claims(annual growth as % of broad money) in Private sector in 2009 to that in 2010?
Give a very brief answer. 0.16. What is the ratio of the Claims(annual growth as % of broad money) of Domestic economy in 2009 to that in 2011?
Provide a succinct answer. 0.14. What is the ratio of the Claims(annual growth as % of broad money) in Private sector in 2009 to that in 2011?
Give a very brief answer. 0.15. What is the ratio of the Claims(annual growth as % of broad money) in Central government in 2010 to that in 2011?
Your answer should be compact. 0.81. What is the ratio of the Claims(annual growth as % of broad money) of Domestic economy in 2010 to that in 2011?
Your answer should be compact. 0.8. What is the ratio of the Claims(annual growth as % of broad money) in Private sector in 2010 to that in 2011?
Offer a very short reply. 0.95. What is the difference between the highest and the second highest Claims(annual growth as % of broad money) in Central government?
Ensure brevity in your answer.  2.14. What is the difference between the highest and the second highest Claims(annual growth as % of broad money) of Domestic economy?
Give a very brief answer. 2.13. What is the difference between the highest and the second highest Claims(annual growth as % of broad money) in Private sector?
Make the answer very short. 2.45. What is the difference between the highest and the lowest Claims(annual growth as % of broad money) of Central government?
Provide a short and direct response. 4.91. What is the difference between the highest and the lowest Claims(annual growth as % of broad money) in Domestic economy?
Offer a terse response. 18.81. What is the difference between the highest and the lowest Claims(annual growth as % of broad money) of Private sector?
Ensure brevity in your answer.  16.93. 